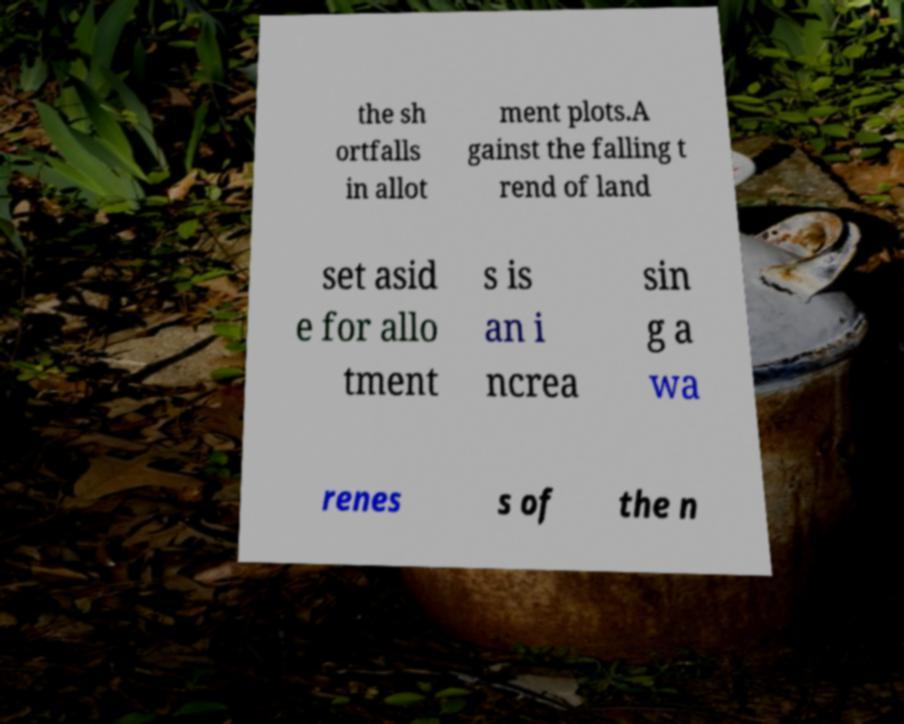Can you read and provide the text displayed in the image?This photo seems to have some interesting text. Can you extract and type it out for me? the sh ortfalls in allot ment plots.A gainst the falling t rend of land set asid e for allo tment s is an i ncrea sin g a wa renes s of the n 